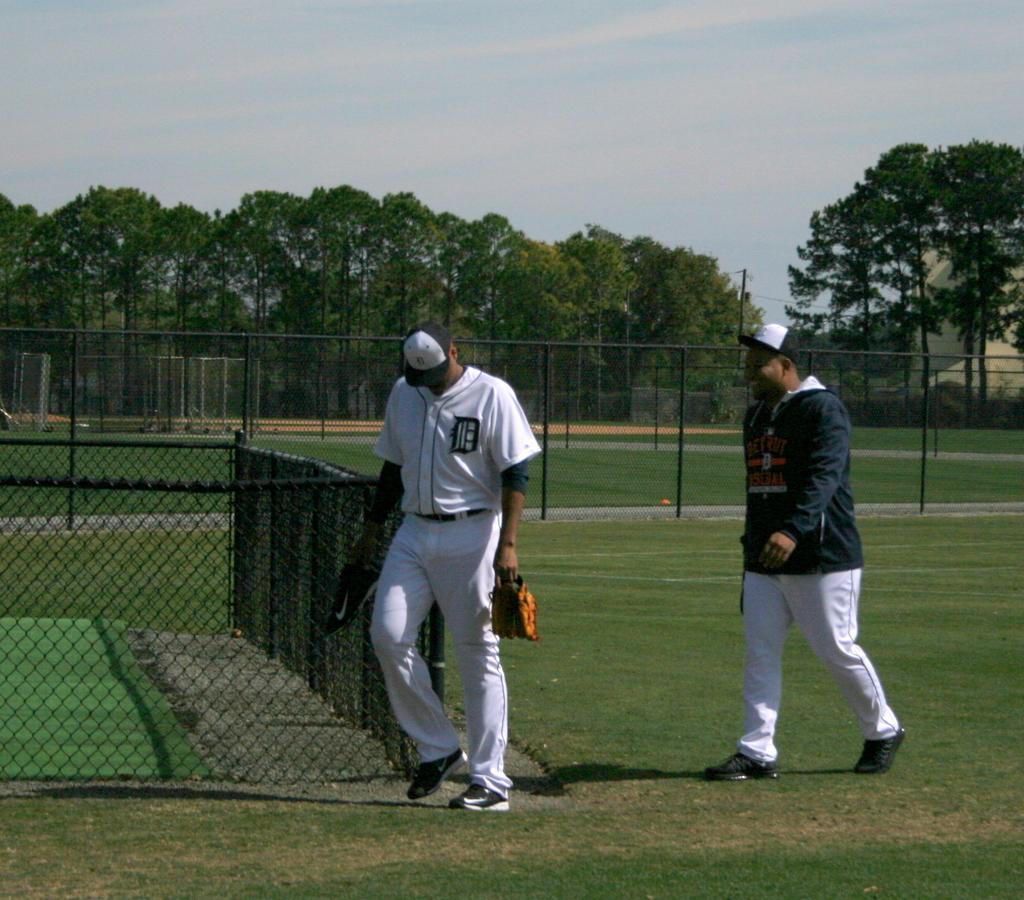How would you summarize this image in a sentence or two? In this picture there are two men in the center of the image on the grassland and there is a net boundary and trees in the background area of the image. 